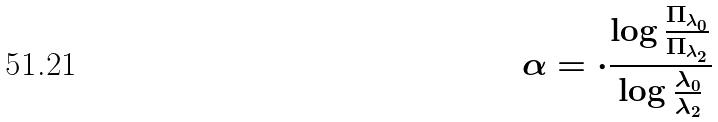Convert formula to latex. <formula><loc_0><loc_0><loc_500><loc_500>\alpha = \cdot \frac { \log \frac { \Pi _ { \lambda _ { 0 } } } { \Pi _ { \lambda _ { 2 } } } } { \log \frac { \lambda _ { 0 } } { \lambda _ { 2 } } }</formula> 